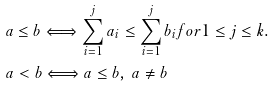<formula> <loc_0><loc_0><loc_500><loc_500>& a \leq b \Longleftrightarrow \sum _ { i = 1 } ^ { j } a _ { i } \leq \sum _ { i = 1 } ^ { j } b _ { i } f o r 1 \leq j \leq k . \\ & a < b \Longleftrightarrow a \leq b , \, a \ne b</formula> 